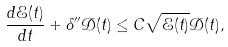<formula> <loc_0><loc_0><loc_500><loc_500>\frac { d \mathcal { E } ( t ) } { d t } + \delta ^ { \prime \prime } \mathcal { D } ( t ) \leq C \sqrt { \mathcal { E } ( t ) } \mathcal { D } ( t ) ,</formula> 